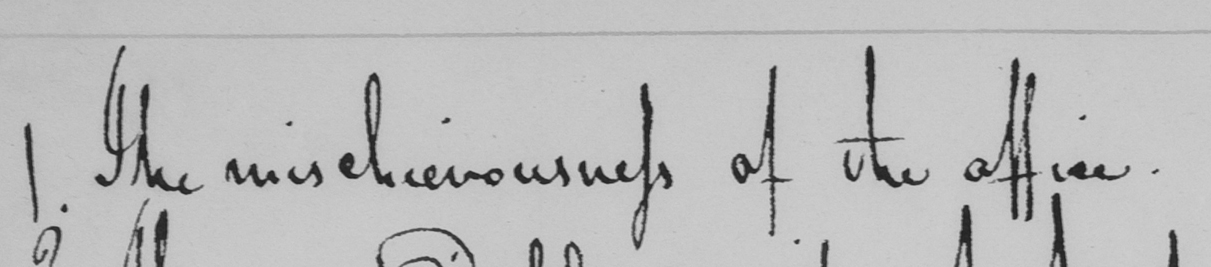Can you tell me what this handwritten text says? 1 . The mischievousness of the office . 